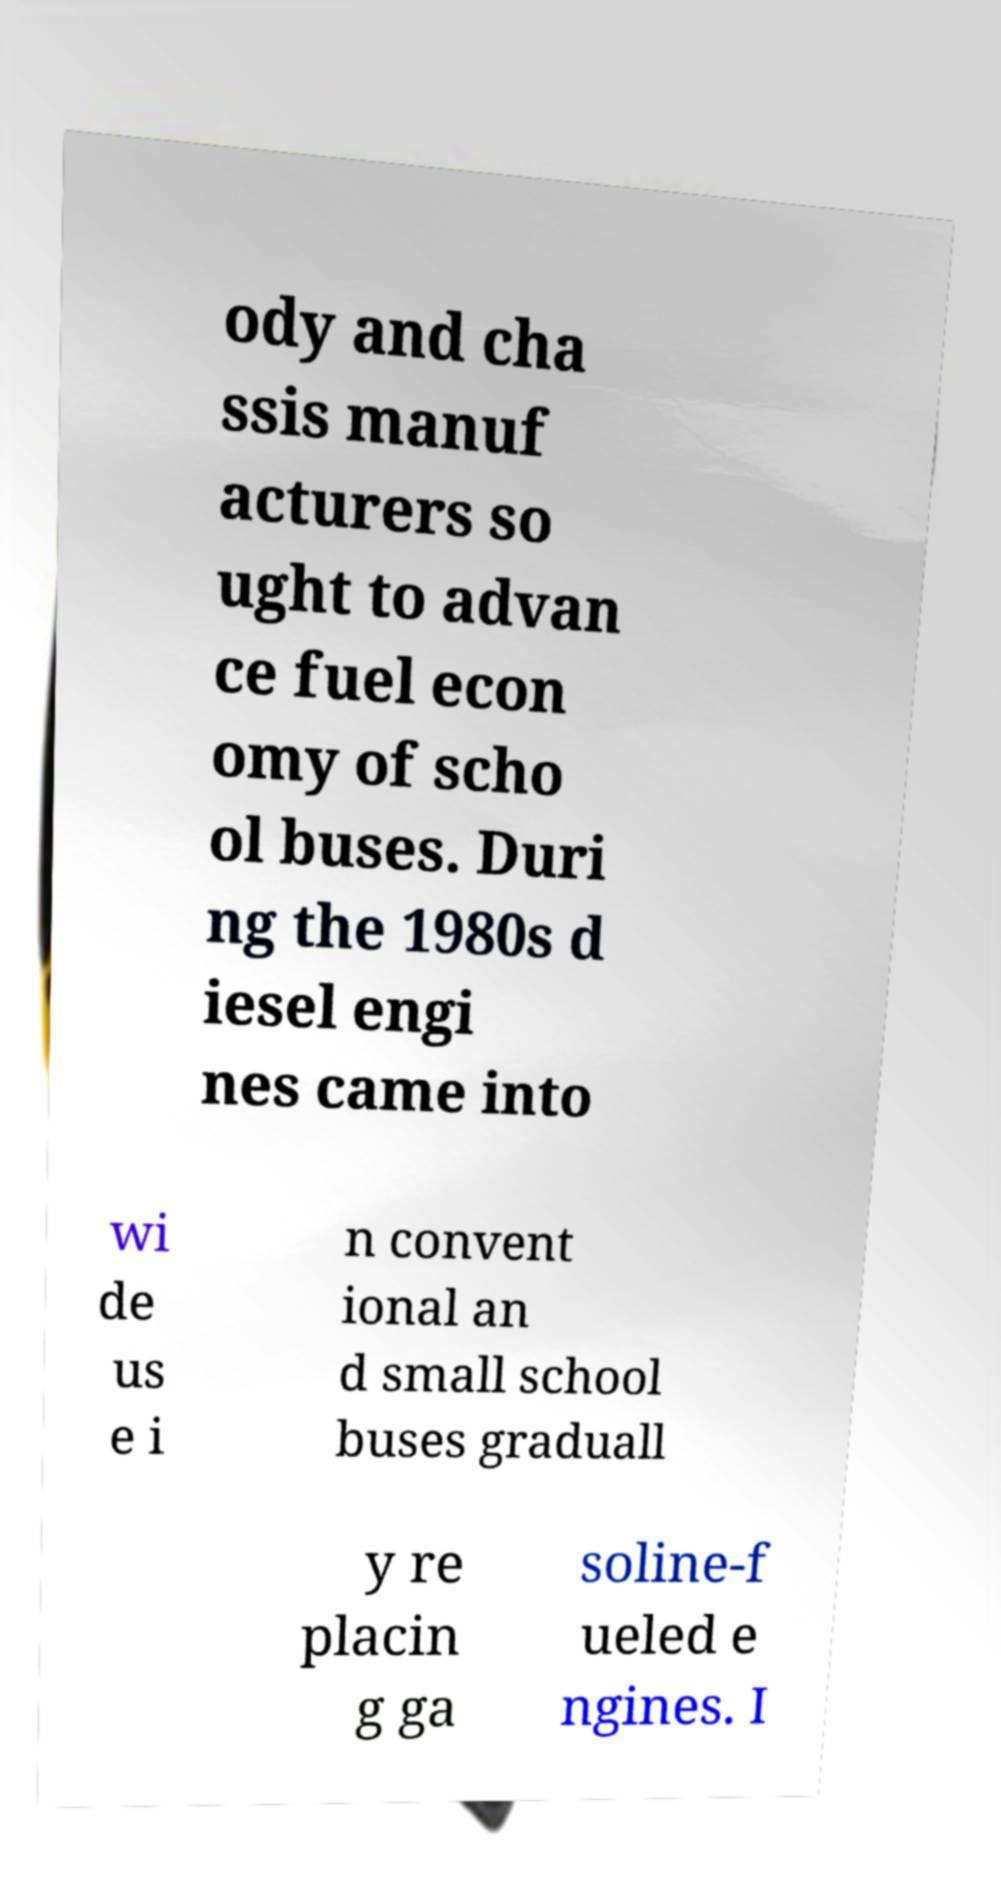There's text embedded in this image that I need extracted. Can you transcribe it verbatim? ody and cha ssis manuf acturers so ught to advan ce fuel econ omy of scho ol buses. Duri ng the 1980s d iesel engi nes came into wi de us e i n convent ional an d small school buses graduall y re placin g ga soline-f ueled e ngines. I 